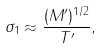<formula> <loc_0><loc_0><loc_500><loc_500>\sigma _ { 1 } \approx \frac { ( M ^ { \prime } ) ^ { 1 / 2 } } { T ^ { \prime } } ,</formula> 